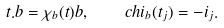Convert formula to latex. <formula><loc_0><loc_0><loc_500><loc_500>t . b = \chi _ { b } ( t ) b , \quad c h i _ { b } ( t _ { j } ) = - i _ { j } .</formula> 